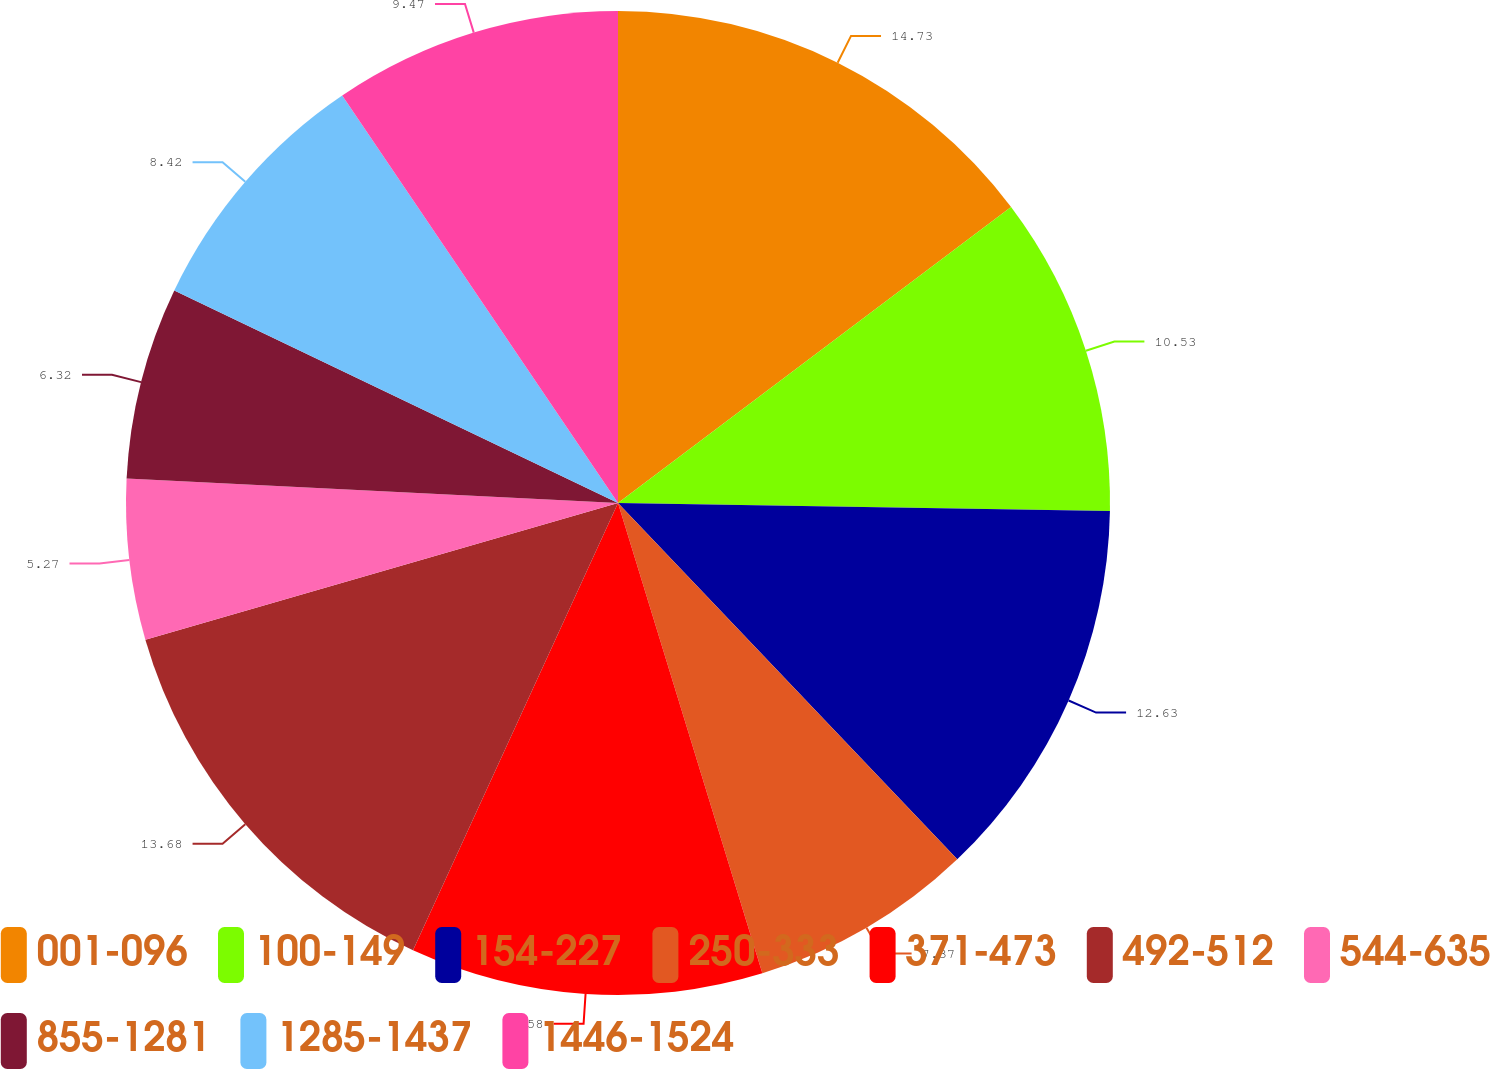<chart> <loc_0><loc_0><loc_500><loc_500><pie_chart><fcel>001-096<fcel>100-149<fcel>154-227<fcel>250-333<fcel>371-473<fcel>492-512<fcel>544-635<fcel>855-1281<fcel>1285-1437<fcel>1446-1524<nl><fcel>14.73%<fcel>10.53%<fcel>12.63%<fcel>7.37%<fcel>11.58%<fcel>13.68%<fcel>5.27%<fcel>6.32%<fcel>8.42%<fcel>9.47%<nl></chart> 